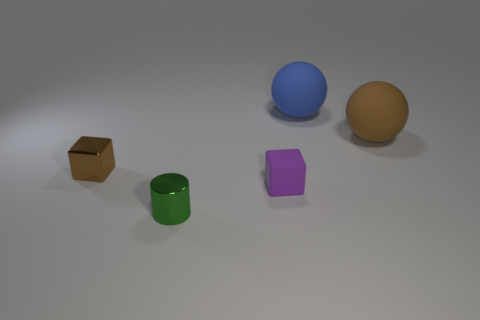Add 5 green metal things. How many objects exist? 10 Subtract all spheres. How many objects are left? 3 Add 2 brown cubes. How many brown cubes are left? 3 Add 4 purple matte things. How many purple matte things exist? 5 Subtract 0 cyan cubes. How many objects are left? 5 Subtract all tiny cyan matte things. Subtract all matte cubes. How many objects are left? 4 